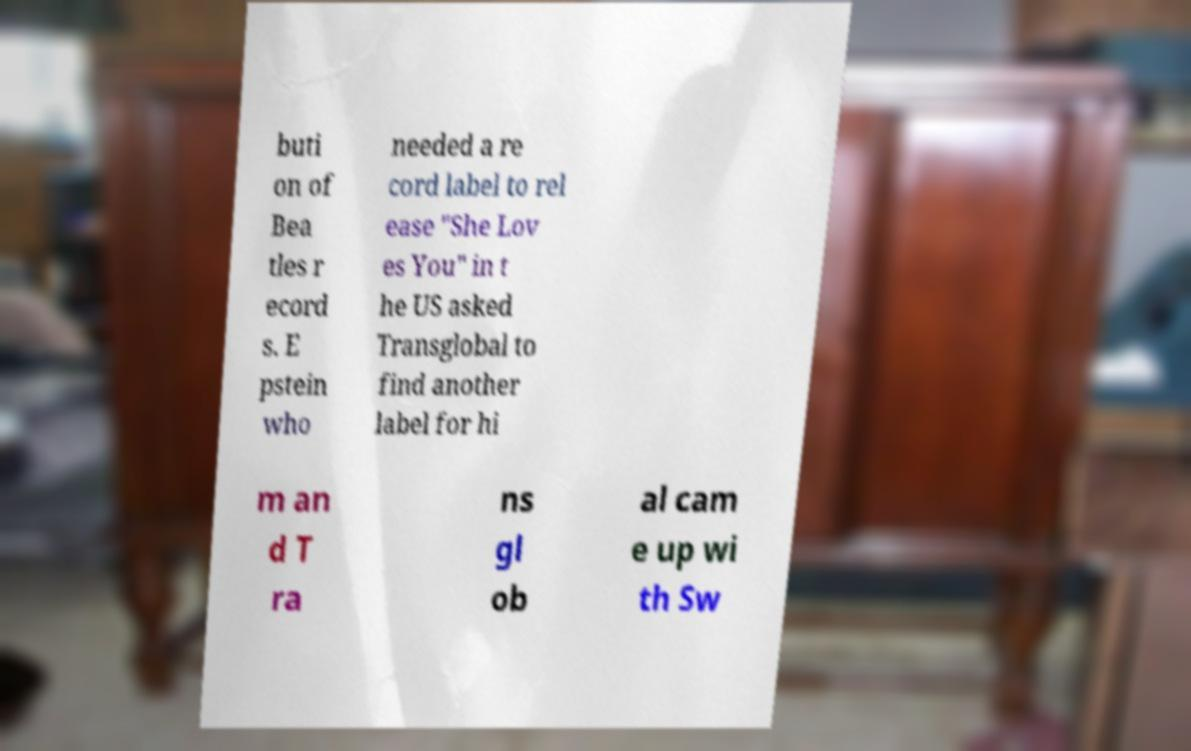Could you extract and type out the text from this image? buti on of Bea tles r ecord s. E pstein who needed a re cord label to rel ease "She Lov es You" in t he US asked Transglobal to find another label for hi m an d T ra ns gl ob al cam e up wi th Sw 